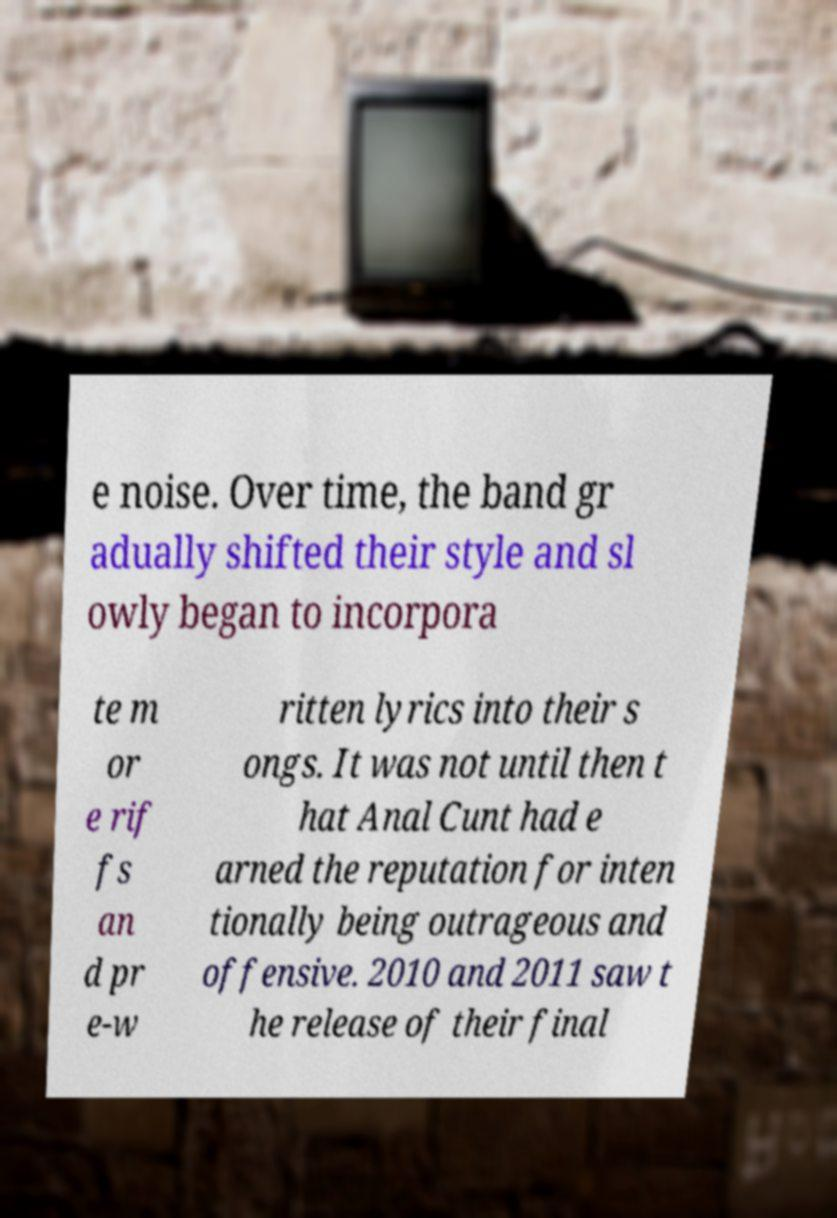I need the written content from this picture converted into text. Can you do that? e noise. Over time, the band gr adually shifted their style and sl owly began to incorpora te m or e rif fs an d pr e-w ritten lyrics into their s ongs. It was not until then t hat Anal Cunt had e arned the reputation for inten tionally being outrageous and offensive. 2010 and 2011 saw t he release of their final 